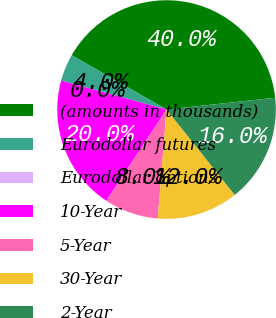Convert chart. <chart><loc_0><loc_0><loc_500><loc_500><pie_chart><fcel>(amounts in thousands)<fcel>Eurodollar futures<fcel>Eurodollar options<fcel>10-Year<fcel>5-Year<fcel>30-Year<fcel>2-Year<nl><fcel>40.0%<fcel>4.0%<fcel>0.0%<fcel>20.0%<fcel>8.0%<fcel>12.0%<fcel>16.0%<nl></chart> 